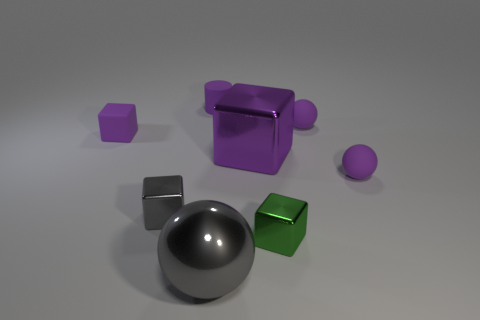Add 1 rubber balls. How many objects exist? 9 Subtract 0 red cubes. How many objects are left? 8 Subtract all purple spheres. How many were subtracted if there are1purple spheres left? 1 Subtract all cylinders. How many objects are left? 7 Subtract 4 blocks. How many blocks are left? 0 Subtract all green balls. Subtract all blue cylinders. How many balls are left? 3 Subtract all gray cylinders. How many yellow balls are left? 0 Subtract all tiny metallic blocks. Subtract all tiny purple rubber things. How many objects are left? 2 Add 3 small purple rubber things. How many small purple rubber things are left? 7 Add 5 tiny blocks. How many tiny blocks exist? 8 